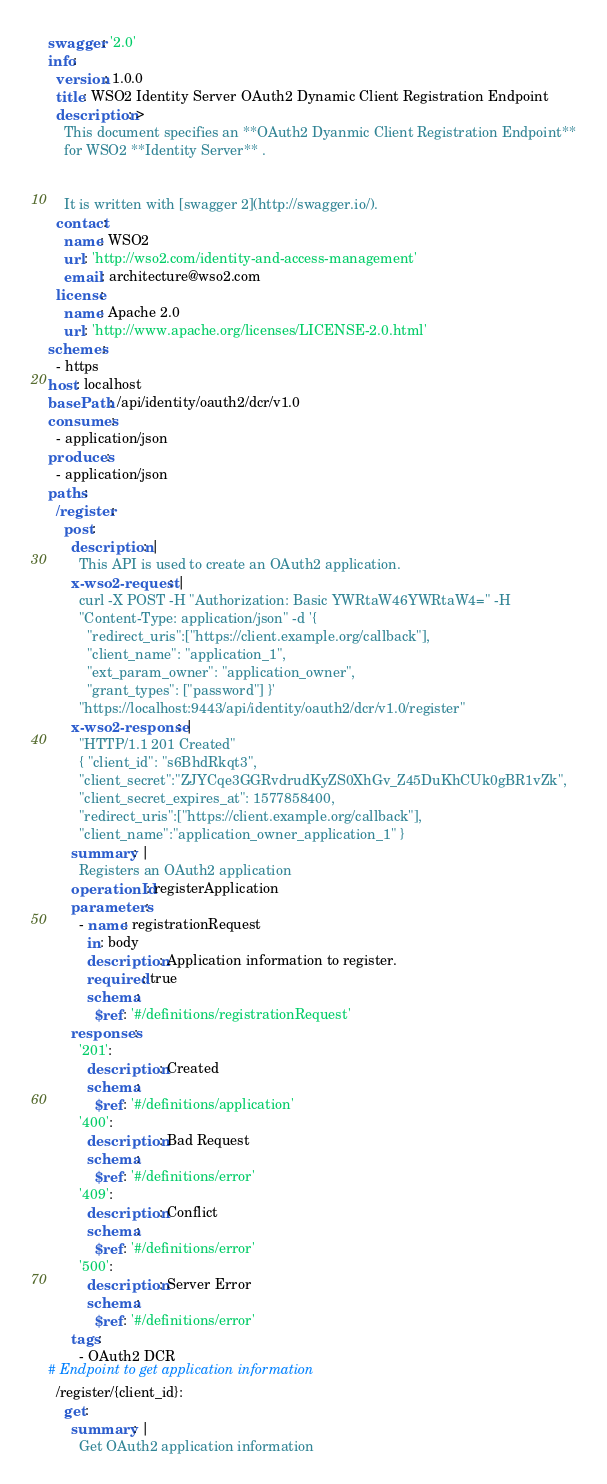<code> <loc_0><loc_0><loc_500><loc_500><_YAML_>swagger: '2.0'
info:
  version: 1.0.0
  title: WSO2 Identity Server OAuth2 Dynamic Client Registration Endpoint
  description: >
    This document specifies an **OAuth2 Dyanmic Client Registration Endpoint**
    for WSO2 **Identity Server** .


    It is written with [swagger 2](http://swagger.io/).
  contact:
    name: WSO2
    url: 'http://wso2.com/identity-and-access-management'
    email: architecture@wso2.com
  license:
    name: Apache 2.0
    url: 'http://www.apache.org/licenses/LICENSE-2.0.html'
schemes:
  - https
host: localhost
basePath: /api/identity/oauth2/dcr/v1.0
consumes:
  - application/json
produces:
  - application/json
paths:
  /register:
    post:
      description: |
        This API is used to create an OAuth2 application.
      x-wso2-request: |
        curl -X POST -H "Authorization: Basic YWRtaW46YWRtaW4=" -H
        "Content-Type: application/json" -d '{
          "redirect_uris":["https://client.example.org/callback"],
          "client_name": "application_1",
          "ext_param_owner": "application_owner",
          "grant_types": ["password"] }'
        "https://localhost:9443/api/identity/oauth2/dcr/v1.0/register"
      x-wso2-response: |
        "HTTP/1.1 201 Created"
        { "client_id": "s6BhdRkqt3",
        "client_secret":"ZJYCqe3GGRvdrudKyZS0XhGv_Z45DuKhCUk0gBR1vZk",
        "client_secret_expires_at": 1577858400,
        "redirect_uris":["https://client.example.org/callback"],
        "client_name":"application_owner_application_1" }
      summary: |
        Registers an OAuth2 application
      operationId: registerApplication
      parameters:
        - name: registrationRequest
          in: body
          description: Application information to register.
          required: true
          schema:
            $ref: '#/definitions/registrationRequest'
      responses:
        '201':
          description: Created
          schema:
            $ref: '#/definitions/application'
        '400':
          description: Bad Request
          schema:
            $ref: '#/definitions/error'
        '409':
          description: Conflict
          schema:
            $ref: '#/definitions/error'
        '500':
          description: Server Error
          schema:
            $ref: '#/definitions/error'
      tags:
        - OAuth2 DCR
# Endpoint to get application information
  /register/{client_id}:
    get:
      summary: |
        Get OAuth2 application information</code> 